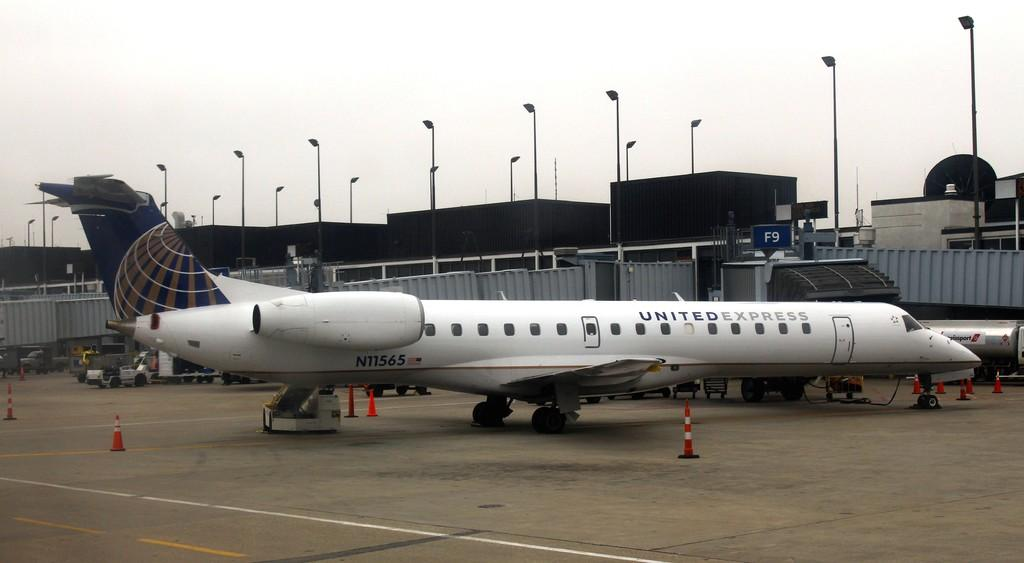What is the main subject of the image? The main subject of the image is a plane. What other objects can be seen in the image? There are traffic cones, a vehicle, a building, a street lamp, and the sky visible in the image. Can you describe the vehicle in the image? The vehicle in the image is not specified, but it is present alongside the other objects. What is the purpose of the traffic cones in the image? The purpose of the traffic cones in the image is not clear, but they are likely used for traffic control or to indicate a construction area. What type of hair can be seen on the plane in the image? There is no hair present on the plane in the image; it is a vehicle and does not have hair. 